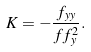<formula> <loc_0><loc_0><loc_500><loc_500>K = - \frac { f _ { y y } } { f f _ { y } ^ { 2 } } .</formula> 